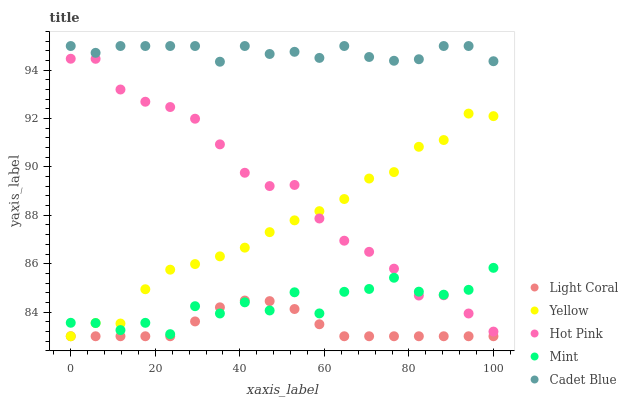Does Light Coral have the minimum area under the curve?
Answer yes or no. Yes. Does Cadet Blue have the maximum area under the curve?
Answer yes or no. Yes. Does Hot Pink have the minimum area under the curve?
Answer yes or no. No. Does Hot Pink have the maximum area under the curve?
Answer yes or no. No. Is Light Coral the smoothest?
Answer yes or no. Yes. Is Mint the roughest?
Answer yes or no. Yes. Is Cadet Blue the smoothest?
Answer yes or no. No. Is Cadet Blue the roughest?
Answer yes or no. No. Does Light Coral have the lowest value?
Answer yes or no. Yes. Does Hot Pink have the lowest value?
Answer yes or no. No. Does Cadet Blue have the highest value?
Answer yes or no. Yes. Does Hot Pink have the highest value?
Answer yes or no. No. Is Mint less than Cadet Blue?
Answer yes or no. Yes. Is Cadet Blue greater than Mint?
Answer yes or no. Yes. Does Yellow intersect Mint?
Answer yes or no. Yes. Is Yellow less than Mint?
Answer yes or no. No. Is Yellow greater than Mint?
Answer yes or no. No. Does Mint intersect Cadet Blue?
Answer yes or no. No. 